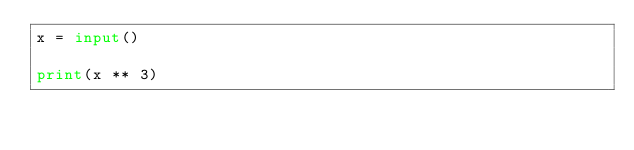<code> <loc_0><loc_0><loc_500><loc_500><_Python_>x = input()

print(x ** 3)</code> 